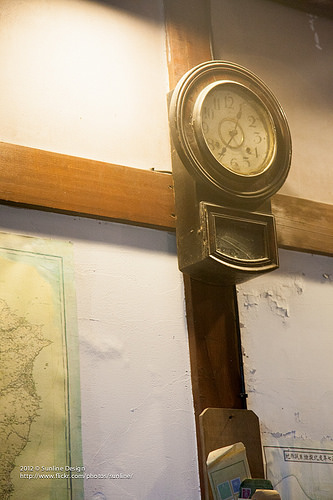<image>
Is the clock on the wall? Yes. Looking at the image, I can see the clock is positioned on top of the wall, with the wall providing support. Is the clock in front of the cross? Yes. The clock is positioned in front of the cross, appearing closer to the camera viewpoint. 